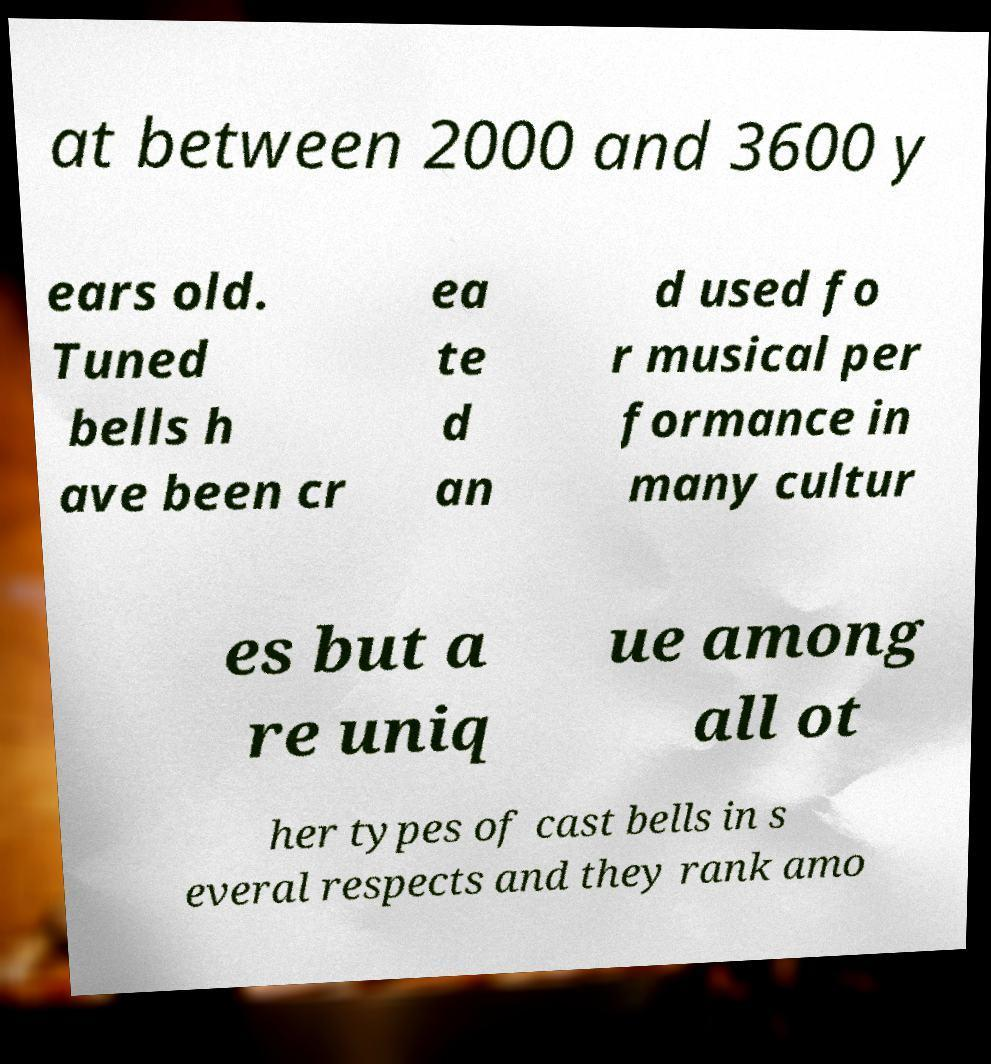Could you extract and type out the text from this image? at between 2000 and 3600 y ears old. Tuned bells h ave been cr ea te d an d used fo r musical per formance in many cultur es but a re uniq ue among all ot her types of cast bells in s everal respects and they rank amo 